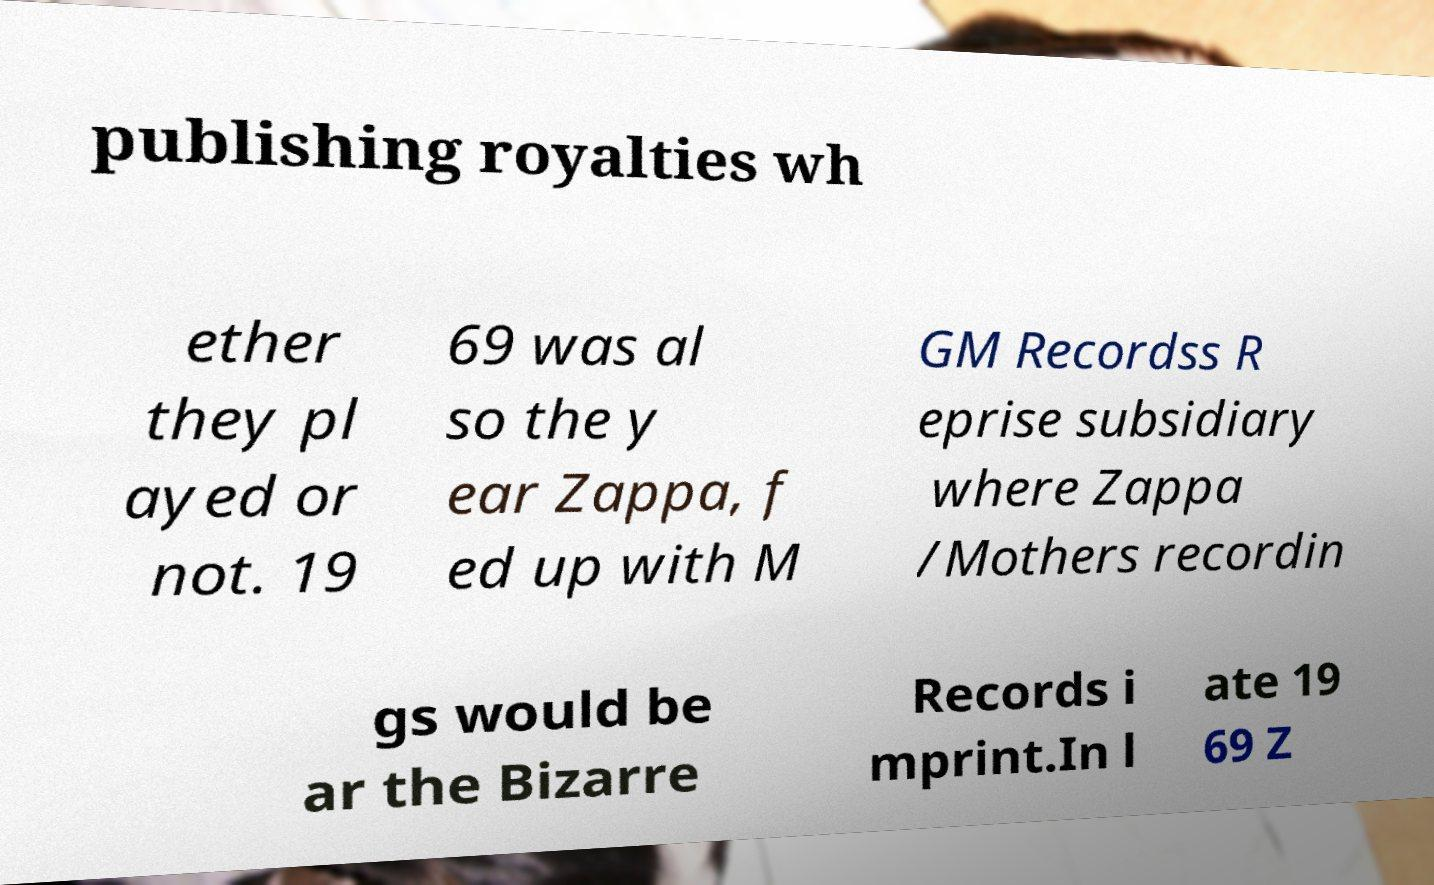Can you accurately transcribe the text from the provided image for me? publishing royalties wh ether they pl ayed or not. 19 69 was al so the y ear Zappa, f ed up with M GM Recordss R eprise subsidiary where Zappa /Mothers recordin gs would be ar the Bizarre Records i mprint.In l ate 19 69 Z 